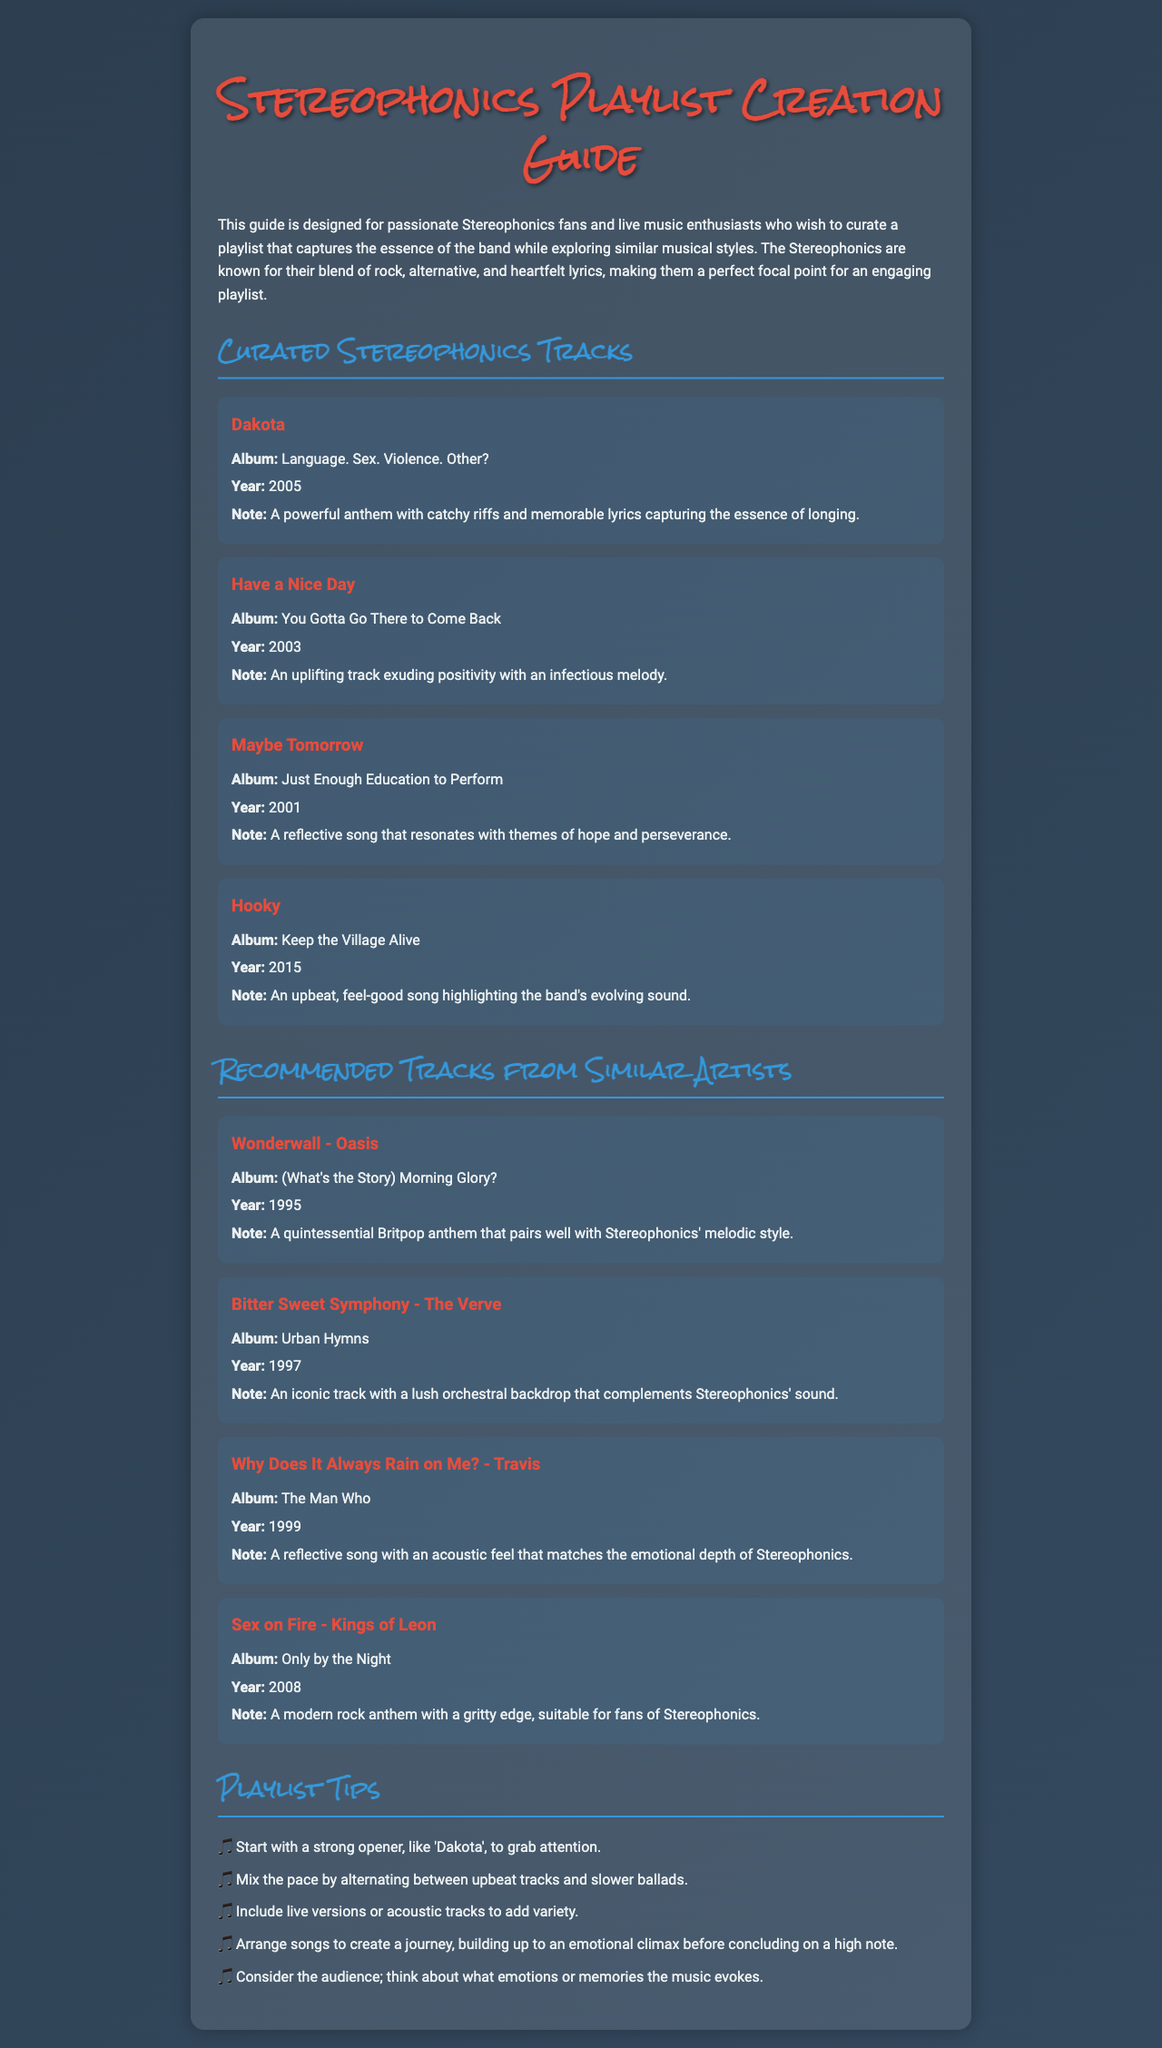What is the title of the document? The title is displayed prominently in the header of the document, introducing the main topic.
Answer: Stereophonics Playlist Creation Guide What is the first curated track listed? The first track mentioned in the curated section is the first item listed under "Curated Stereophonics Tracks."
Answer: Dakota In what year was "Maybe Tomorrow" released? The release year is provided in parentheses next to the track title.
Answer: 2001 What are two similar artists mentioned in the document? The artists are listed under "Recommended Tracks from Similar Artists" and are examples to explore songs with similar styles.
Answer: Oasis, The Verve What is one tip for creating a playlist? The tips are listed under "Playlist Tips," with each offering different advice on track arrangement.
Answer: Start with a strong opener How many curated Stereophonics tracks are provided? The number of tracks can be counted from the section listing curated songs.
Answer: Four What is the album for "Wonderwall"? The album information is provided in parentheses next to the track title in the recommended section.
Answer: (What's the Story) Morning Glory? Which year was "Sex on Fire" released? The release year is provided next to the track title in the recommended tracks section.
Answer: 2008 What kind of music styles does the document suggest for the playlist? The styles are generally characterized by the descriptions given regarding the band's sound and the recommendations.
Answer: Rock, alternative 